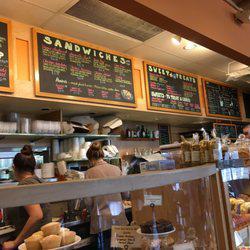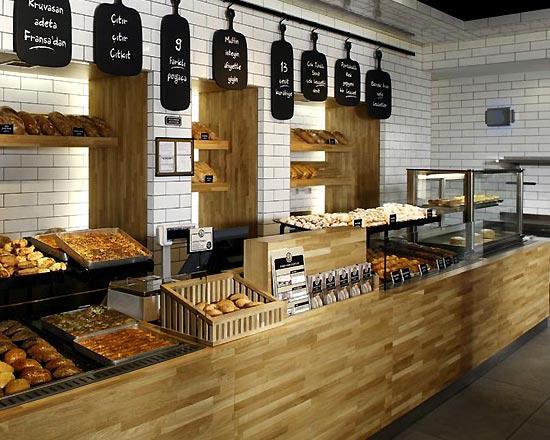The first image is the image on the left, the second image is the image on the right. Evaluate the accuracy of this statement regarding the images: "At least one woman with her hair up is working behind the counter of one bakery.". Is it true? Answer yes or no. Yes. The first image is the image on the left, the second image is the image on the right. Evaluate the accuracy of this statement regarding the images: "The only humans visible appear to be workers.". Is it true? Answer yes or no. Yes. 